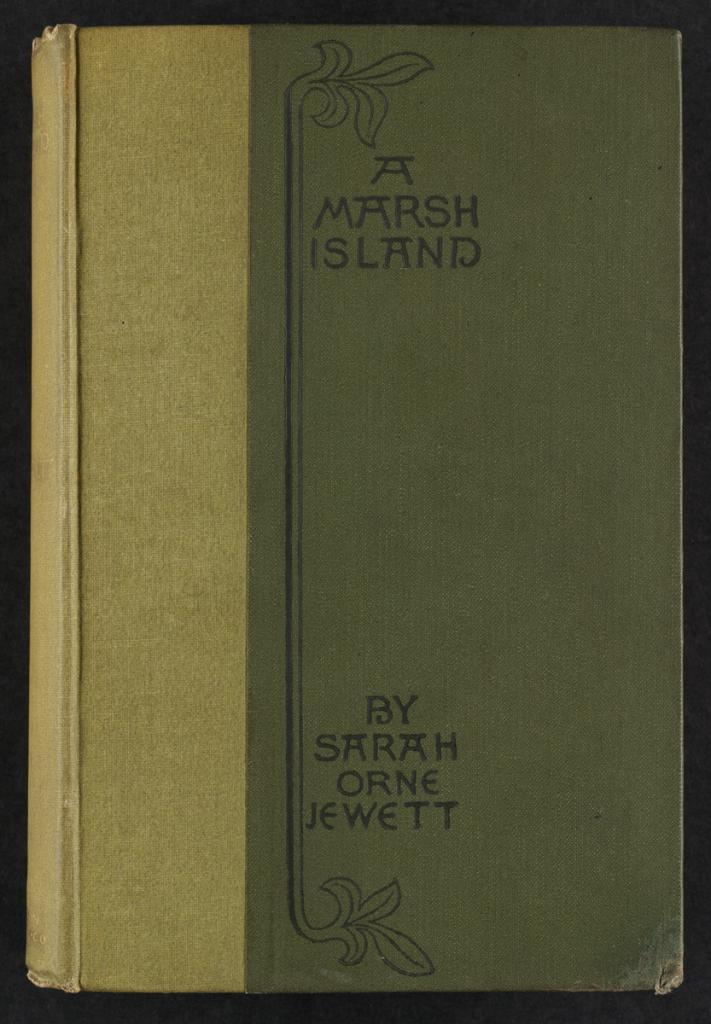Who is the author of this book?
Provide a succinct answer. Sarah orne jewett. What is the book title?
Make the answer very short. A marsh island. 